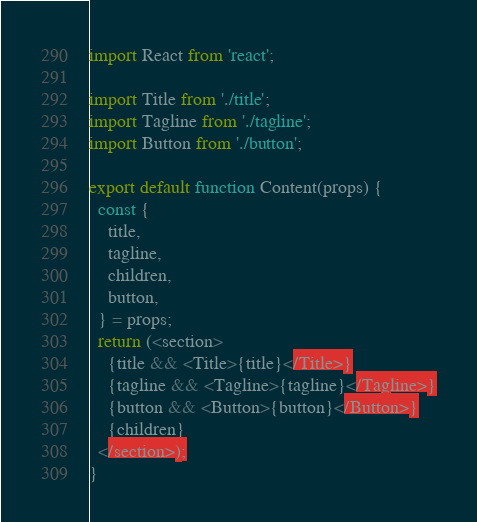<code> <loc_0><loc_0><loc_500><loc_500><_JavaScript_>import React from 'react';

import Title from './title';
import Tagline from './tagline';
import Button from './button';

export default function Content(props) {
  const {
    title,
    tagline,
    children,
    button,
  } = props;
  return (<section>
    {title && <Title>{title}</Title>}
    {tagline && <Tagline>{tagline}</Tagline>}
    {button && <Button>{button}</Button>}
    {children}
  </section>);
}
</code> 